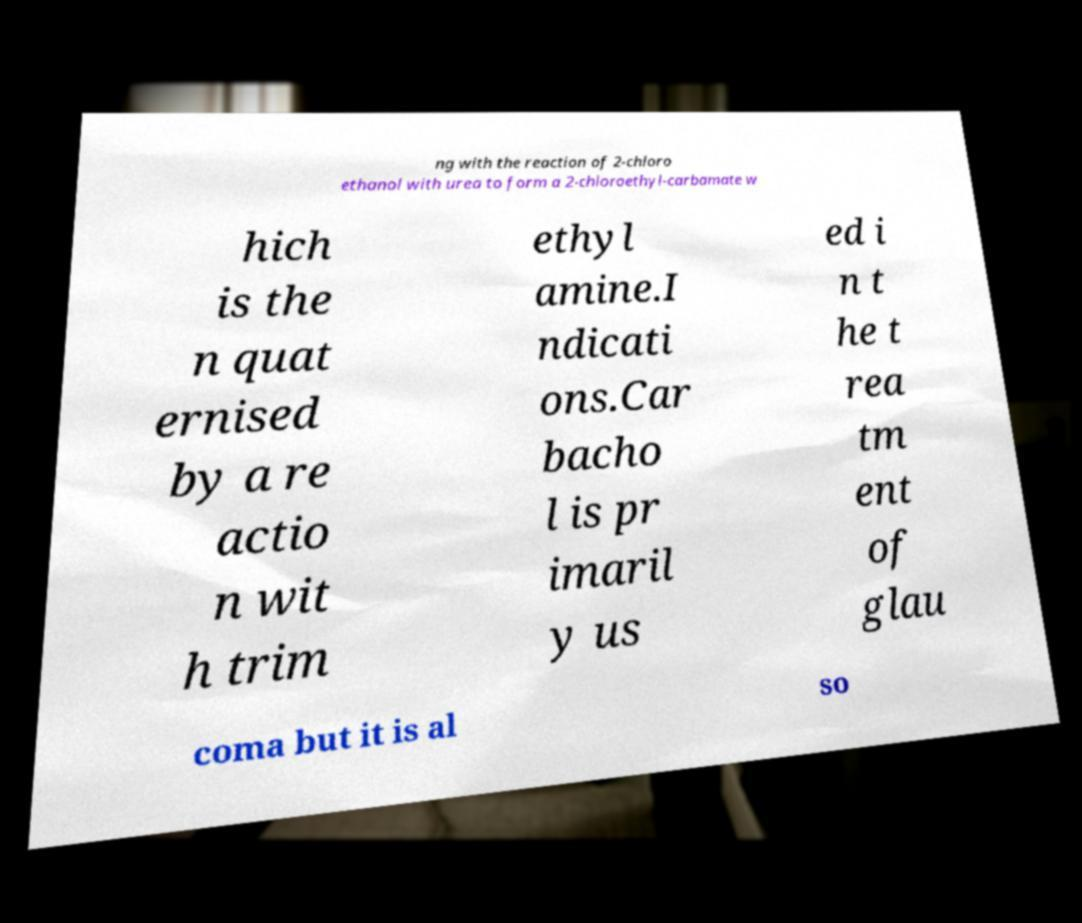I need the written content from this picture converted into text. Can you do that? ng with the reaction of 2-chloro ethanol with urea to form a 2-chloroethyl-carbamate w hich is the n quat ernised by a re actio n wit h trim ethyl amine.I ndicati ons.Car bacho l is pr imaril y us ed i n t he t rea tm ent of glau coma but it is al so 